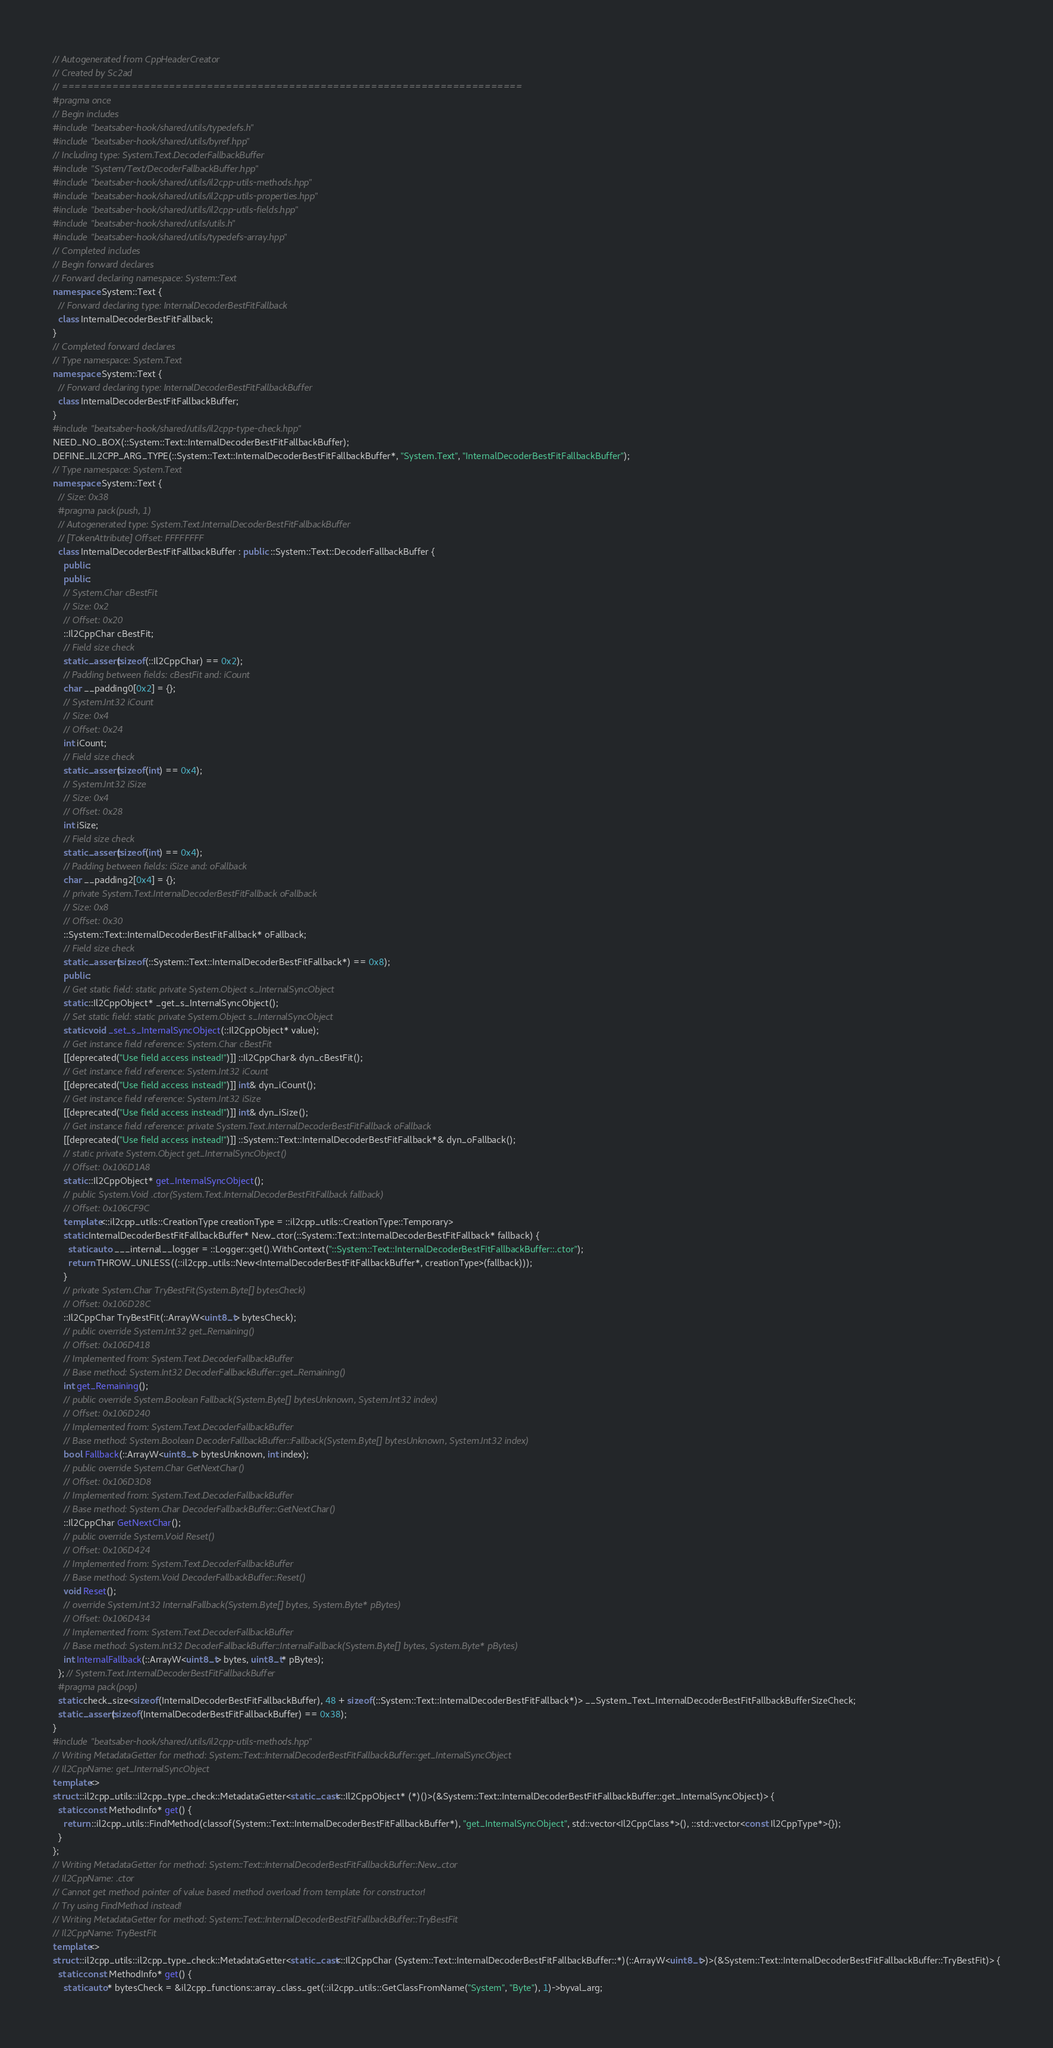Convert code to text. <code><loc_0><loc_0><loc_500><loc_500><_C++_>// Autogenerated from CppHeaderCreator
// Created by Sc2ad
// =========================================================================
#pragma once
// Begin includes
#include "beatsaber-hook/shared/utils/typedefs.h"
#include "beatsaber-hook/shared/utils/byref.hpp"
// Including type: System.Text.DecoderFallbackBuffer
#include "System/Text/DecoderFallbackBuffer.hpp"
#include "beatsaber-hook/shared/utils/il2cpp-utils-methods.hpp"
#include "beatsaber-hook/shared/utils/il2cpp-utils-properties.hpp"
#include "beatsaber-hook/shared/utils/il2cpp-utils-fields.hpp"
#include "beatsaber-hook/shared/utils/utils.h"
#include "beatsaber-hook/shared/utils/typedefs-array.hpp"
// Completed includes
// Begin forward declares
// Forward declaring namespace: System::Text
namespace System::Text {
  // Forward declaring type: InternalDecoderBestFitFallback
  class InternalDecoderBestFitFallback;
}
// Completed forward declares
// Type namespace: System.Text
namespace System::Text {
  // Forward declaring type: InternalDecoderBestFitFallbackBuffer
  class InternalDecoderBestFitFallbackBuffer;
}
#include "beatsaber-hook/shared/utils/il2cpp-type-check.hpp"
NEED_NO_BOX(::System::Text::InternalDecoderBestFitFallbackBuffer);
DEFINE_IL2CPP_ARG_TYPE(::System::Text::InternalDecoderBestFitFallbackBuffer*, "System.Text", "InternalDecoderBestFitFallbackBuffer");
// Type namespace: System.Text
namespace System::Text {
  // Size: 0x38
  #pragma pack(push, 1)
  // Autogenerated type: System.Text.InternalDecoderBestFitFallbackBuffer
  // [TokenAttribute] Offset: FFFFFFFF
  class InternalDecoderBestFitFallbackBuffer : public ::System::Text::DecoderFallbackBuffer {
    public:
    public:
    // System.Char cBestFit
    // Size: 0x2
    // Offset: 0x20
    ::Il2CppChar cBestFit;
    // Field size check
    static_assert(sizeof(::Il2CppChar) == 0x2);
    // Padding between fields: cBestFit and: iCount
    char __padding0[0x2] = {};
    // System.Int32 iCount
    // Size: 0x4
    // Offset: 0x24
    int iCount;
    // Field size check
    static_assert(sizeof(int) == 0x4);
    // System.Int32 iSize
    // Size: 0x4
    // Offset: 0x28
    int iSize;
    // Field size check
    static_assert(sizeof(int) == 0x4);
    // Padding between fields: iSize and: oFallback
    char __padding2[0x4] = {};
    // private System.Text.InternalDecoderBestFitFallback oFallback
    // Size: 0x8
    // Offset: 0x30
    ::System::Text::InternalDecoderBestFitFallback* oFallback;
    // Field size check
    static_assert(sizeof(::System::Text::InternalDecoderBestFitFallback*) == 0x8);
    public:
    // Get static field: static private System.Object s_InternalSyncObject
    static ::Il2CppObject* _get_s_InternalSyncObject();
    // Set static field: static private System.Object s_InternalSyncObject
    static void _set_s_InternalSyncObject(::Il2CppObject* value);
    // Get instance field reference: System.Char cBestFit
    [[deprecated("Use field access instead!")]] ::Il2CppChar& dyn_cBestFit();
    // Get instance field reference: System.Int32 iCount
    [[deprecated("Use field access instead!")]] int& dyn_iCount();
    // Get instance field reference: System.Int32 iSize
    [[deprecated("Use field access instead!")]] int& dyn_iSize();
    // Get instance field reference: private System.Text.InternalDecoderBestFitFallback oFallback
    [[deprecated("Use field access instead!")]] ::System::Text::InternalDecoderBestFitFallback*& dyn_oFallback();
    // static private System.Object get_InternalSyncObject()
    // Offset: 0x106D1A8
    static ::Il2CppObject* get_InternalSyncObject();
    // public System.Void .ctor(System.Text.InternalDecoderBestFitFallback fallback)
    // Offset: 0x106CF9C
    template<::il2cpp_utils::CreationType creationType = ::il2cpp_utils::CreationType::Temporary>
    static InternalDecoderBestFitFallbackBuffer* New_ctor(::System::Text::InternalDecoderBestFitFallback* fallback) {
      static auto ___internal__logger = ::Logger::get().WithContext("::System::Text::InternalDecoderBestFitFallbackBuffer::.ctor");
      return THROW_UNLESS((::il2cpp_utils::New<InternalDecoderBestFitFallbackBuffer*, creationType>(fallback)));
    }
    // private System.Char TryBestFit(System.Byte[] bytesCheck)
    // Offset: 0x106D28C
    ::Il2CppChar TryBestFit(::ArrayW<uint8_t> bytesCheck);
    // public override System.Int32 get_Remaining()
    // Offset: 0x106D418
    // Implemented from: System.Text.DecoderFallbackBuffer
    // Base method: System.Int32 DecoderFallbackBuffer::get_Remaining()
    int get_Remaining();
    // public override System.Boolean Fallback(System.Byte[] bytesUnknown, System.Int32 index)
    // Offset: 0x106D240
    // Implemented from: System.Text.DecoderFallbackBuffer
    // Base method: System.Boolean DecoderFallbackBuffer::Fallback(System.Byte[] bytesUnknown, System.Int32 index)
    bool Fallback(::ArrayW<uint8_t> bytesUnknown, int index);
    // public override System.Char GetNextChar()
    // Offset: 0x106D3D8
    // Implemented from: System.Text.DecoderFallbackBuffer
    // Base method: System.Char DecoderFallbackBuffer::GetNextChar()
    ::Il2CppChar GetNextChar();
    // public override System.Void Reset()
    // Offset: 0x106D424
    // Implemented from: System.Text.DecoderFallbackBuffer
    // Base method: System.Void DecoderFallbackBuffer::Reset()
    void Reset();
    // override System.Int32 InternalFallback(System.Byte[] bytes, System.Byte* pBytes)
    // Offset: 0x106D434
    // Implemented from: System.Text.DecoderFallbackBuffer
    // Base method: System.Int32 DecoderFallbackBuffer::InternalFallback(System.Byte[] bytes, System.Byte* pBytes)
    int InternalFallback(::ArrayW<uint8_t> bytes, uint8_t* pBytes);
  }; // System.Text.InternalDecoderBestFitFallbackBuffer
  #pragma pack(pop)
  static check_size<sizeof(InternalDecoderBestFitFallbackBuffer), 48 + sizeof(::System::Text::InternalDecoderBestFitFallback*)> __System_Text_InternalDecoderBestFitFallbackBufferSizeCheck;
  static_assert(sizeof(InternalDecoderBestFitFallbackBuffer) == 0x38);
}
#include "beatsaber-hook/shared/utils/il2cpp-utils-methods.hpp"
// Writing MetadataGetter for method: System::Text::InternalDecoderBestFitFallbackBuffer::get_InternalSyncObject
// Il2CppName: get_InternalSyncObject
template<>
struct ::il2cpp_utils::il2cpp_type_check::MetadataGetter<static_cast<::Il2CppObject* (*)()>(&System::Text::InternalDecoderBestFitFallbackBuffer::get_InternalSyncObject)> {
  static const MethodInfo* get() {
    return ::il2cpp_utils::FindMethod(classof(System::Text::InternalDecoderBestFitFallbackBuffer*), "get_InternalSyncObject", std::vector<Il2CppClass*>(), ::std::vector<const Il2CppType*>{});
  }
};
// Writing MetadataGetter for method: System::Text::InternalDecoderBestFitFallbackBuffer::New_ctor
// Il2CppName: .ctor
// Cannot get method pointer of value based method overload from template for constructor!
// Try using FindMethod instead!
// Writing MetadataGetter for method: System::Text::InternalDecoderBestFitFallbackBuffer::TryBestFit
// Il2CppName: TryBestFit
template<>
struct ::il2cpp_utils::il2cpp_type_check::MetadataGetter<static_cast<::Il2CppChar (System::Text::InternalDecoderBestFitFallbackBuffer::*)(::ArrayW<uint8_t>)>(&System::Text::InternalDecoderBestFitFallbackBuffer::TryBestFit)> {
  static const MethodInfo* get() {
    static auto* bytesCheck = &il2cpp_functions::array_class_get(::il2cpp_utils::GetClassFromName("System", "Byte"), 1)->byval_arg;</code> 